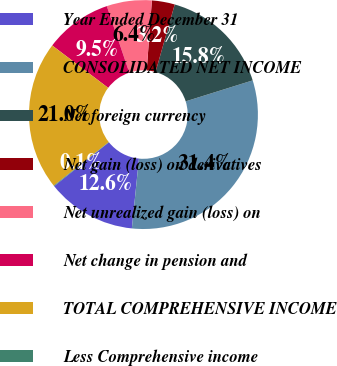<chart> <loc_0><loc_0><loc_500><loc_500><pie_chart><fcel>Year Ended December 31<fcel>CONSOLIDATED NET INCOME<fcel>Net foreign currency<fcel>Net gain (loss) on derivatives<fcel>Net unrealized gain (loss) on<fcel>Net change in pension and<fcel>TOTAL COMPREHENSIVE INCOME<fcel>Less Comprehensive income<nl><fcel>12.63%<fcel>31.44%<fcel>15.77%<fcel>3.23%<fcel>6.36%<fcel>9.5%<fcel>20.98%<fcel>0.09%<nl></chart> 